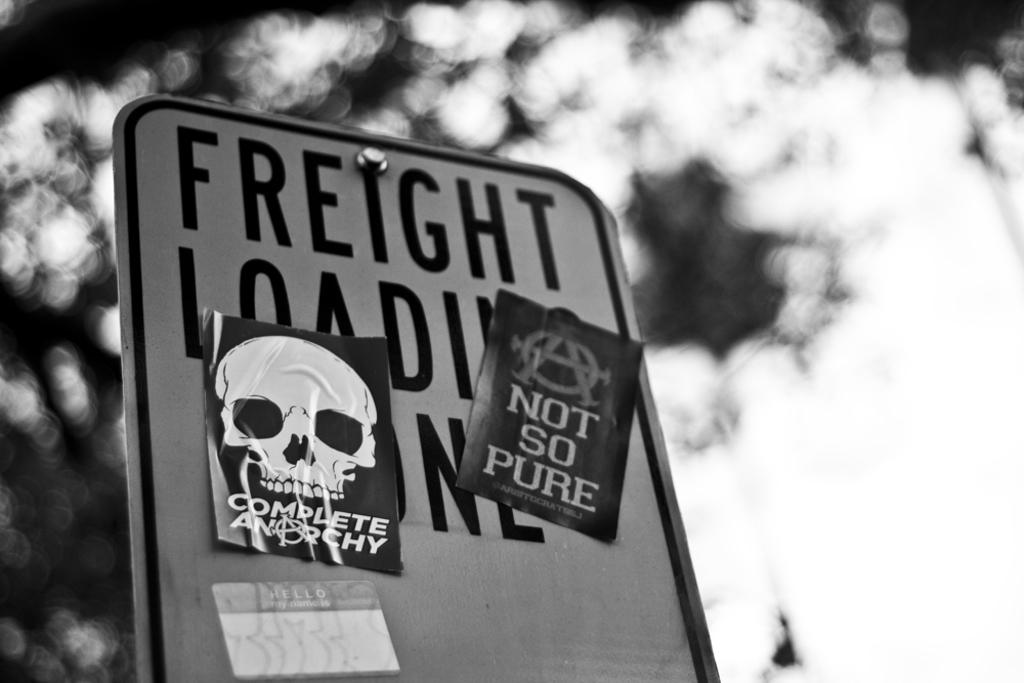What is the main object in the image? There is a board in the image. What is on the board? There are papers attached to the board. What color scheme is used in the image? The image is in black and white. How many books are stacked on the board in the image? There are no books present in the image; it only features a board with papers attached. Is there a boot visible in the image? There is no boot present in the image. 